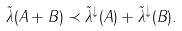Convert formula to latex. <formula><loc_0><loc_0><loc_500><loc_500>\tilde { \lambda } ( A + B ) \prec \tilde { \lambda } ^ { \downarrow } ( A ) + \tilde { \lambda } ^ { \downarrow } ( B ) .</formula> 